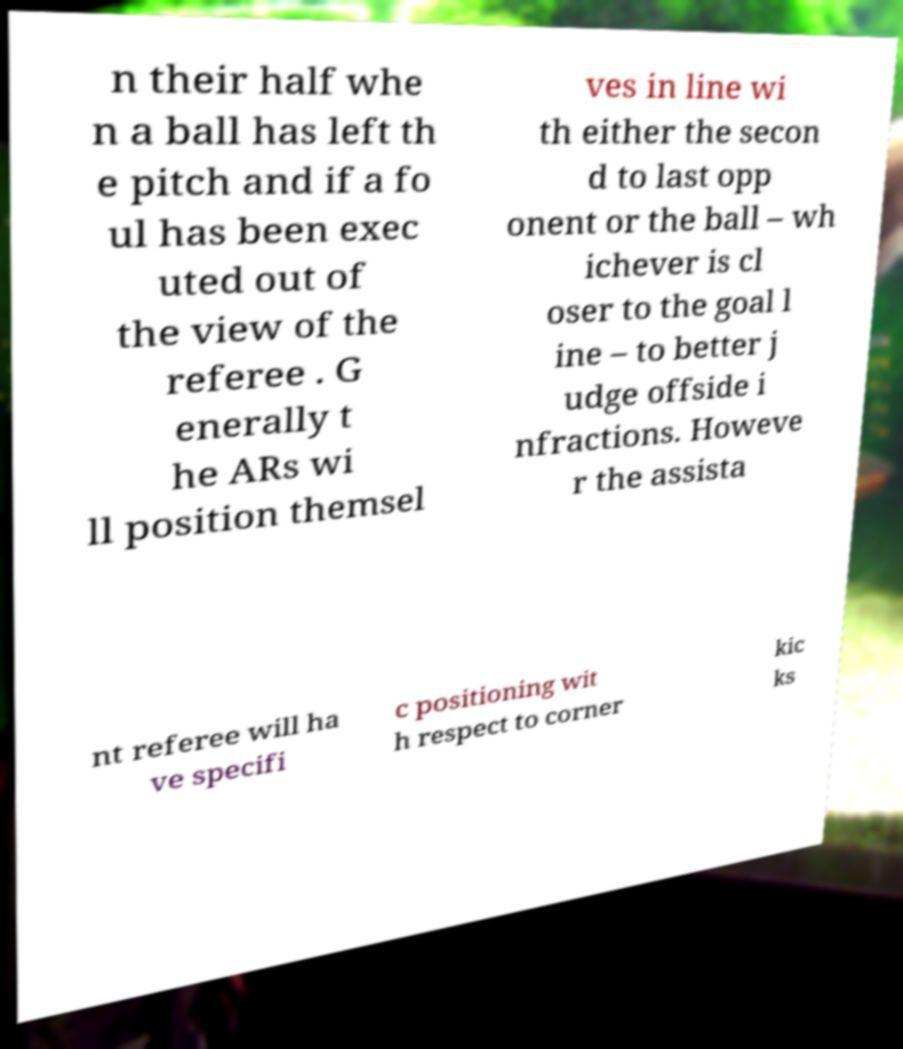I need the written content from this picture converted into text. Can you do that? n their half whe n a ball has left th e pitch and if a fo ul has been exec uted out of the view of the referee . G enerally t he ARs wi ll position themsel ves in line wi th either the secon d to last opp onent or the ball – wh ichever is cl oser to the goal l ine – to better j udge offside i nfractions. Howeve r the assista nt referee will ha ve specifi c positioning wit h respect to corner kic ks 